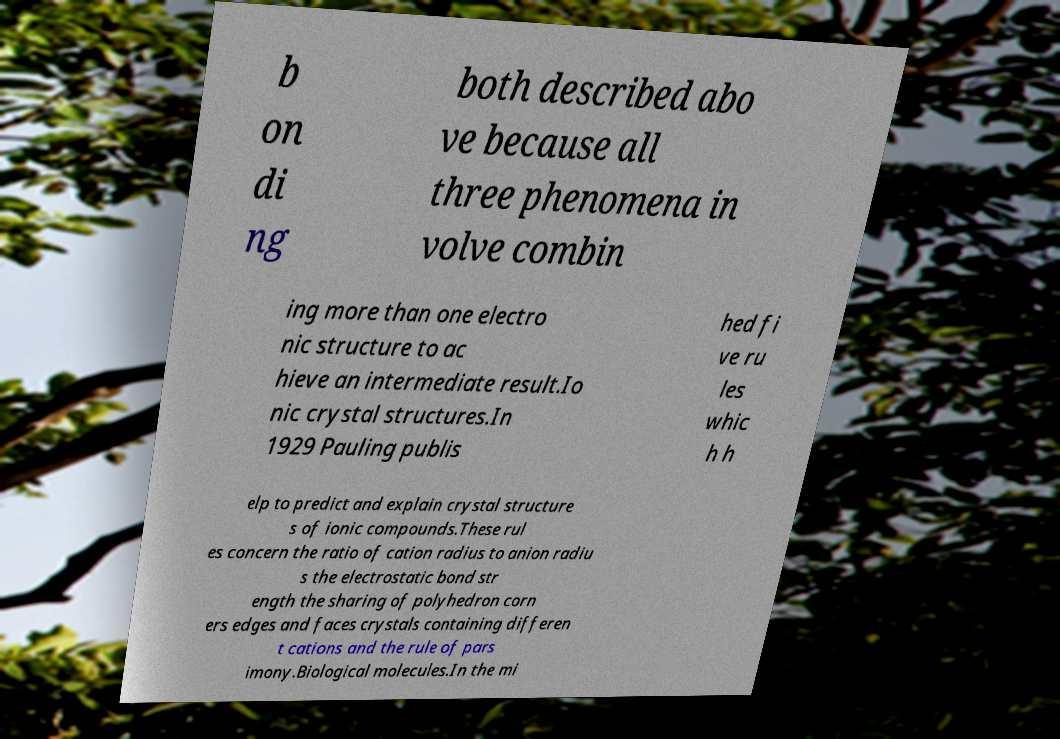Can you accurately transcribe the text from the provided image for me? b on di ng both described abo ve because all three phenomena in volve combin ing more than one electro nic structure to ac hieve an intermediate result.Io nic crystal structures.In 1929 Pauling publis hed fi ve ru les whic h h elp to predict and explain crystal structure s of ionic compounds.These rul es concern the ratio of cation radius to anion radiu s the electrostatic bond str ength the sharing of polyhedron corn ers edges and faces crystals containing differen t cations and the rule of pars imony.Biological molecules.In the mi 